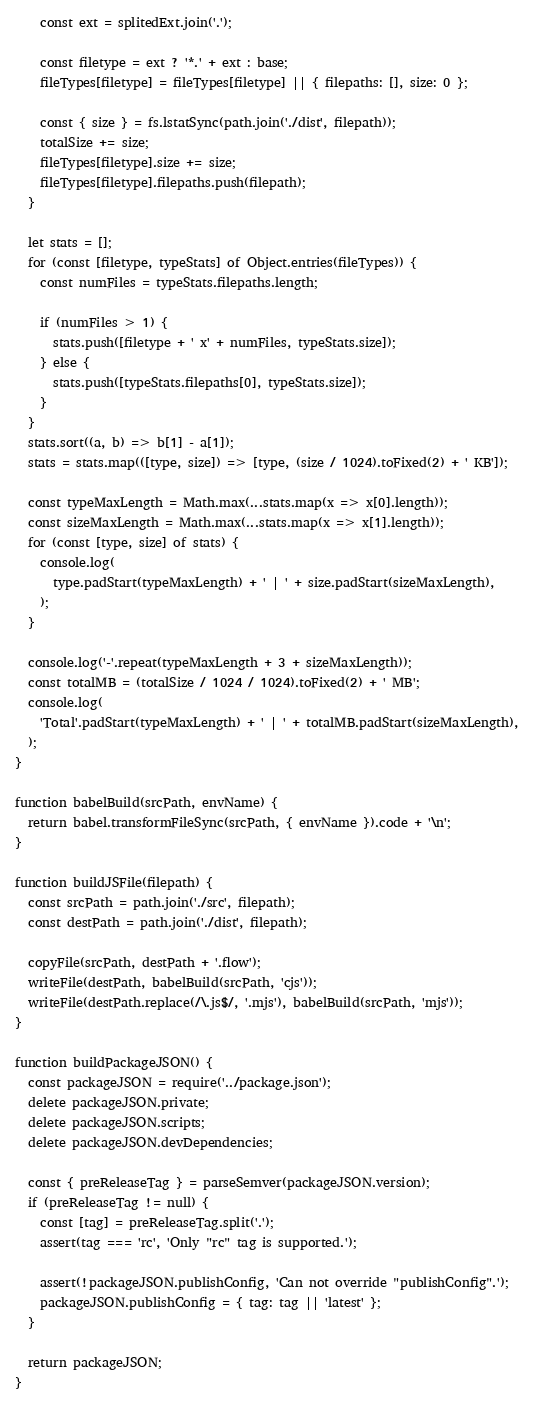<code> <loc_0><loc_0><loc_500><loc_500><_JavaScript_>    const ext = splitedExt.join('.');

    const filetype = ext ? '*.' + ext : base;
    fileTypes[filetype] = fileTypes[filetype] || { filepaths: [], size: 0 };

    const { size } = fs.lstatSync(path.join('./dist', filepath));
    totalSize += size;
    fileTypes[filetype].size += size;
    fileTypes[filetype].filepaths.push(filepath);
  }

  let stats = [];
  for (const [filetype, typeStats] of Object.entries(fileTypes)) {
    const numFiles = typeStats.filepaths.length;

    if (numFiles > 1) {
      stats.push([filetype + ' x' + numFiles, typeStats.size]);
    } else {
      stats.push([typeStats.filepaths[0], typeStats.size]);
    }
  }
  stats.sort((a, b) => b[1] - a[1]);
  stats = stats.map(([type, size]) => [type, (size / 1024).toFixed(2) + ' KB']);

  const typeMaxLength = Math.max(...stats.map(x => x[0].length));
  const sizeMaxLength = Math.max(...stats.map(x => x[1].length));
  for (const [type, size] of stats) {
    console.log(
      type.padStart(typeMaxLength) + ' | ' + size.padStart(sizeMaxLength),
    );
  }

  console.log('-'.repeat(typeMaxLength + 3 + sizeMaxLength));
  const totalMB = (totalSize / 1024 / 1024).toFixed(2) + ' MB';
  console.log(
    'Total'.padStart(typeMaxLength) + ' | ' + totalMB.padStart(sizeMaxLength),
  );
}

function babelBuild(srcPath, envName) {
  return babel.transformFileSync(srcPath, { envName }).code + '\n';
}

function buildJSFile(filepath) {
  const srcPath = path.join('./src', filepath);
  const destPath = path.join('./dist', filepath);

  copyFile(srcPath, destPath + '.flow');
  writeFile(destPath, babelBuild(srcPath, 'cjs'));
  writeFile(destPath.replace(/\.js$/, '.mjs'), babelBuild(srcPath, 'mjs'));
}

function buildPackageJSON() {
  const packageJSON = require('../package.json');
  delete packageJSON.private;
  delete packageJSON.scripts;
  delete packageJSON.devDependencies;

  const { preReleaseTag } = parseSemver(packageJSON.version);
  if (preReleaseTag != null) {
    const [tag] = preReleaseTag.split('.');
    assert(tag === 'rc', 'Only "rc" tag is supported.');

    assert(!packageJSON.publishConfig, 'Can not override "publishConfig".');
    packageJSON.publishConfig = { tag: tag || 'latest' };
  }

  return packageJSON;
}
</code> 